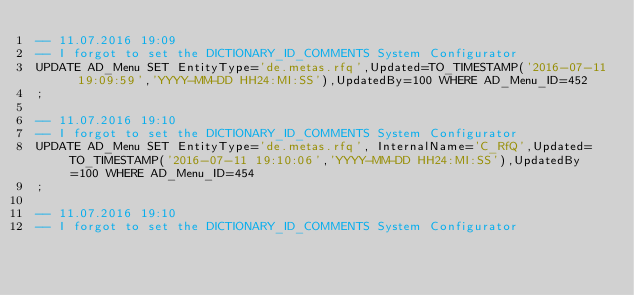Convert code to text. <code><loc_0><loc_0><loc_500><loc_500><_SQL_>-- 11.07.2016 19:09
-- I forgot to set the DICTIONARY_ID_COMMENTS System Configurator
UPDATE AD_Menu SET EntityType='de.metas.rfq',Updated=TO_TIMESTAMP('2016-07-11 19:09:59','YYYY-MM-DD HH24:MI:SS'),UpdatedBy=100 WHERE AD_Menu_ID=452
;

-- 11.07.2016 19:10
-- I forgot to set the DICTIONARY_ID_COMMENTS System Configurator
UPDATE AD_Menu SET EntityType='de.metas.rfq', InternalName='C_RfQ',Updated=TO_TIMESTAMP('2016-07-11 19:10:06','YYYY-MM-DD HH24:MI:SS'),UpdatedBy=100 WHERE AD_Menu_ID=454
;

-- 11.07.2016 19:10
-- I forgot to set the DICTIONARY_ID_COMMENTS System Configurator</code> 